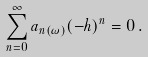<formula> <loc_0><loc_0><loc_500><loc_500>\sum _ { n = 0 } ^ { \infty } a _ { n ( \omega ) } ( - h ) ^ { n } = 0 \, .</formula> 